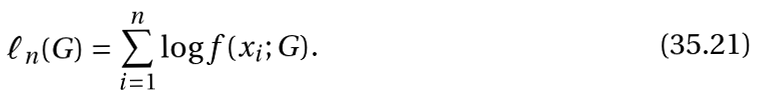Convert formula to latex. <formula><loc_0><loc_0><loc_500><loc_500>\ell _ { n } ( G ) = \sum _ { i = 1 } ^ { n } \log f ( x _ { i } ; G ) .</formula> 